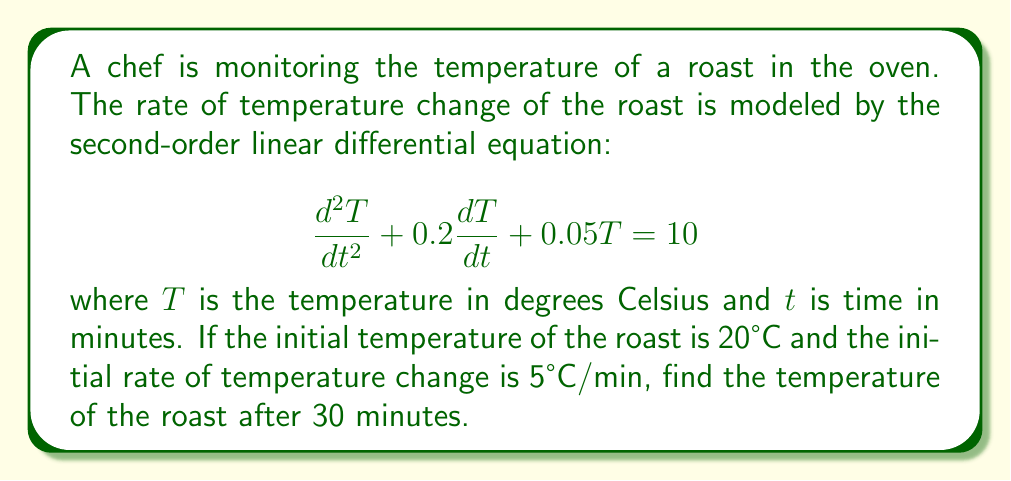Help me with this question. To solve this problem, we need to follow these steps:

1) First, we need to find the general solution of the differential equation. The characteristic equation is:

   $$r^2 + 0.2r + 0.05 = 0$$

2) Solving this quadratic equation:
   
   $$r = \frac{-0.2 \pm \sqrt{0.2^2 - 4(1)(0.05)}}{2(1)} = \frac{-0.2 \pm \sqrt{0.04 - 0.2}}{2} = \frac{-0.2 \pm \sqrt{-0.16}}{2}$$

3) This gives us complex roots: $r = -0.1 \pm 0.2i$

4) The general solution is therefore:

   $$T_h = e^{-0.1t}(C_1\cos(0.2t) + C_2\sin(0.2t))$$

5) The particular solution is a constant: $T_p = 200$

6) So, the complete solution is:

   $$T = e^{-0.1t}(C_1\cos(0.2t) + C_2\sin(0.2t)) + 200$$

7) Now we use the initial conditions to find $C_1$ and $C_2$:
   
   At $t=0$, $T=20$: $20 = C_1 + 200$, so $C_1 = -180$
   
   At $t=0$, $\frac{dT}{dt}=5$: $5 = -0.1C_1 + 0.2C_2$, so $0.2C_2 = 5 + 18 = 23$, and $C_2 = 115$

8) Our final solution is:

   $$T = e^{-0.1t}(-180\cos(0.2t) + 115\sin(0.2t)) + 200$$

9) To find the temperature at $t=30$, we plug in $t=30$:

   $$T(30) = e^{-3}(-180\cos(6) + 115\sin(6)) + 200$$

10) Calculating this gives us the final answer.
Answer: $T(30) \approx 193.4°C$ 